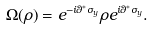<formula> <loc_0><loc_0><loc_500><loc_500>\Omega ( \rho ) = e ^ { - i \theta ^ { * } \sigma _ { y } } \rho e ^ { i \theta ^ { * } \sigma _ { y } } .</formula> 